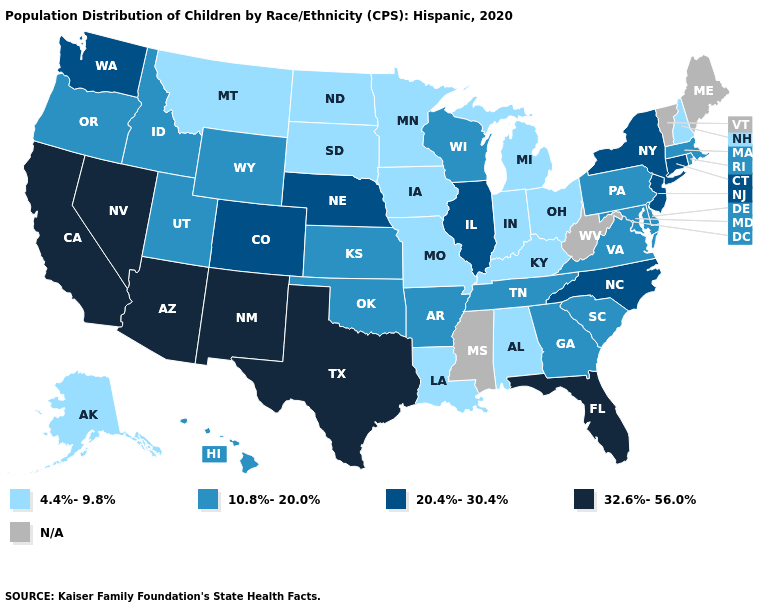What is the lowest value in the West?
Concise answer only. 4.4%-9.8%. Does Florida have the lowest value in the USA?
Concise answer only. No. Name the states that have a value in the range N/A?
Keep it brief. Maine, Mississippi, Vermont, West Virginia. Does the map have missing data?
Short answer required. Yes. Does Oregon have the lowest value in the USA?
Concise answer only. No. Name the states that have a value in the range 20.4%-30.4%?
Answer briefly. Colorado, Connecticut, Illinois, Nebraska, New Jersey, New York, North Carolina, Washington. Among the states that border Maryland , which have the lowest value?
Short answer required. Delaware, Pennsylvania, Virginia. Name the states that have a value in the range 4.4%-9.8%?
Concise answer only. Alabama, Alaska, Indiana, Iowa, Kentucky, Louisiana, Michigan, Minnesota, Missouri, Montana, New Hampshire, North Dakota, Ohio, South Dakota. Which states hav the highest value in the Northeast?
Short answer required. Connecticut, New Jersey, New York. Among the states that border West Virginia , does Kentucky have the lowest value?
Quick response, please. Yes. Does Utah have the lowest value in the West?
Concise answer only. No. Does Louisiana have the lowest value in the South?
Keep it brief. Yes. What is the value of Oregon?
Concise answer only. 10.8%-20.0%. Among the states that border Vermont , which have the lowest value?
Give a very brief answer. New Hampshire. What is the value of Nevada?
Keep it brief. 32.6%-56.0%. 